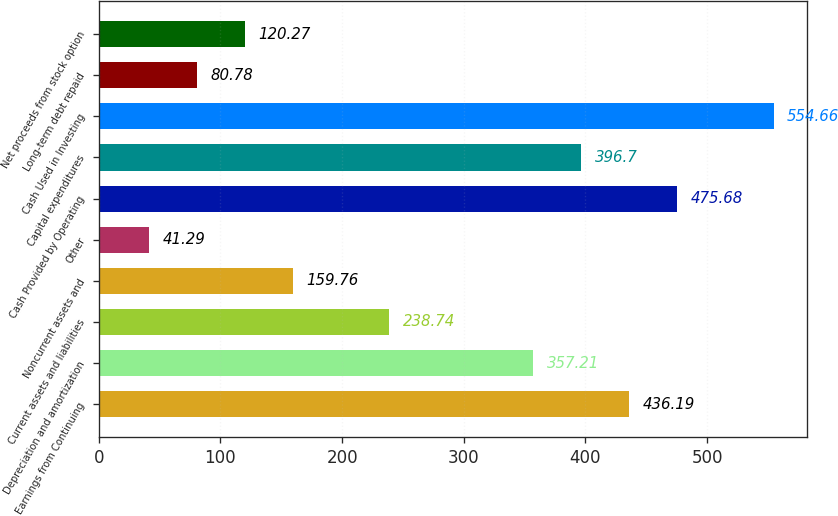<chart> <loc_0><loc_0><loc_500><loc_500><bar_chart><fcel>Earnings from Continuing<fcel>Depreciation and amortization<fcel>Current assets and liabilities<fcel>Noncurrent assets and<fcel>Other<fcel>Cash Provided by Operating<fcel>Capital expenditures<fcel>Cash Used in Investing<fcel>Long-term debt repaid<fcel>Net proceeds from stock option<nl><fcel>436.19<fcel>357.21<fcel>238.74<fcel>159.76<fcel>41.29<fcel>475.68<fcel>396.7<fcel>554.66<fcel>80.78<fcel>120.27<nl></chart> 